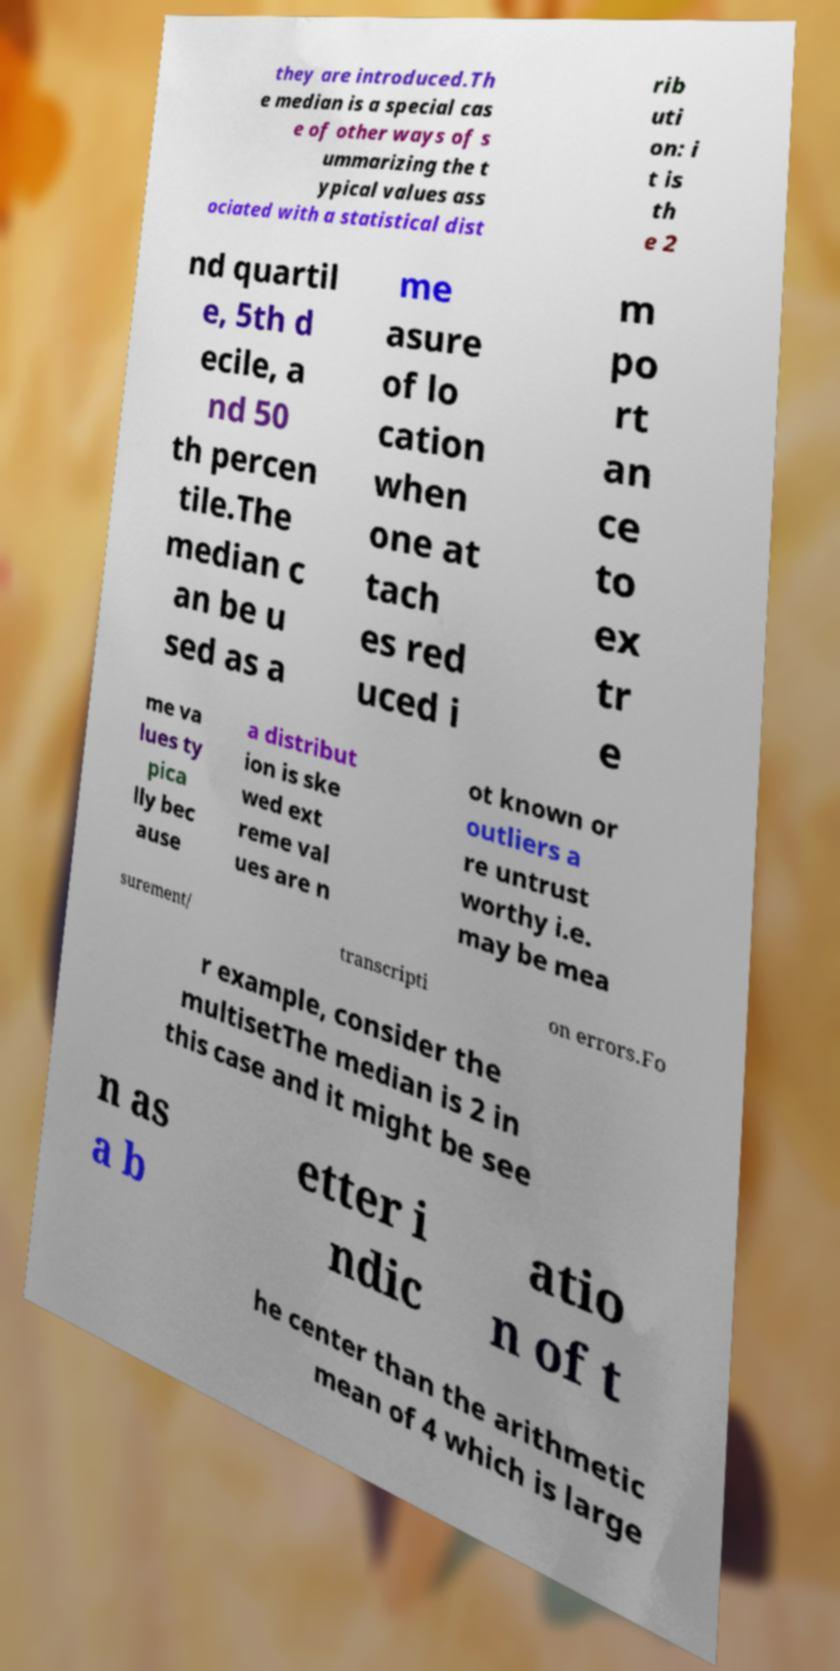Can you read and provide the text displayed in the image?This photo seems to have some interesting text. Can you extract and type it out for me? they are introduced.Th e median is a special cas e of other ways of s ummarizing the t ypical values ass ociated with a statistical dist rib uti on: i t is th e 2 nd quartil e, 5th d ecile, a nd 50 th percen tile.The median c an be u sed as a me asure of lo cation when one at tach es red uced i m po rt an ce to ex tr e me va lues ty pica lly bec ause a distribut ion is ske wed ext reme val ues are n ot known or outliers a re untrust worthy i.e. may be mea surement/ transcripti on errors.Fo r example, consider the multisetThe median is 2 in this case and it might be see n as a b etter i ndic atio n of t he center than the arithmetic mean of 4 which is large 